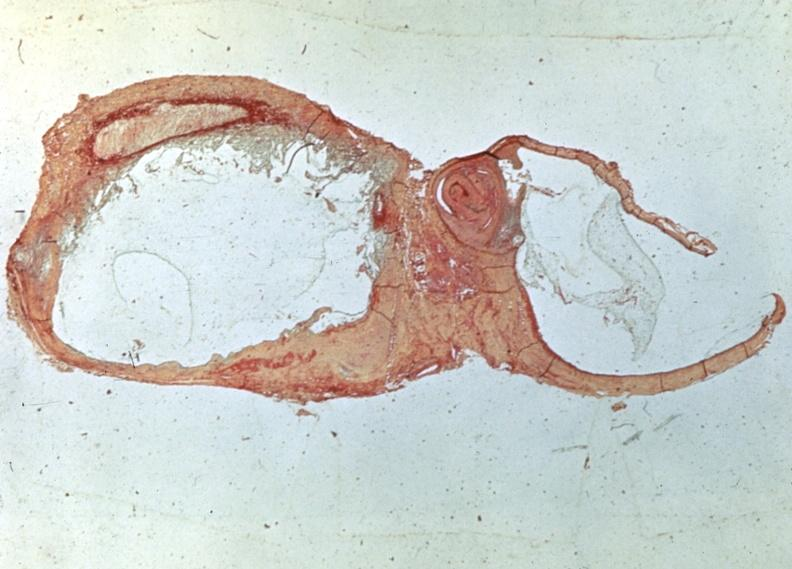what is present?
Answer the question using a single word or phrase. Joints 